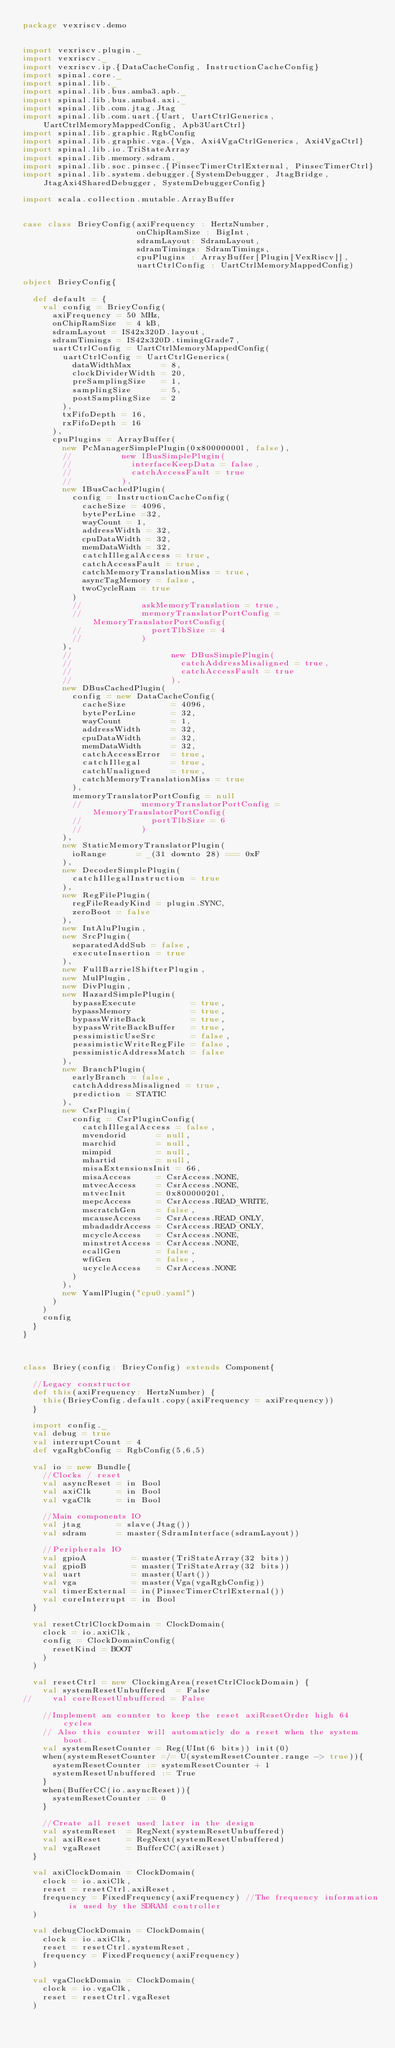Convert code to text. <code><loc_0><loc_0><loc_500><loc_500><_Scala_>package vexriscv.demo


import vexriscv.plugin._
import vexriscv._
import vexriscv.ip.{DataCacheConfig, InstructionCacheConfig}
import spinal.core._
import spinal.lib._
import spinal.lib.bus.amba3.apb._
import spinal.lib.bus.amba4.axi._
import spinal.lib.com.jtag.Jtag
import spinal.lib.com.uart.{Uart, UartCtrlGenerics, UartCtrlMemoryMappedConfig, Apb3UartCtrl}
import spinal.lib.graphic.RgbConfig
import spinal.lib.graphic.vga.{Vga, Axi4VgaCtrlGenerics, Axi4VgaCtrl}
import spinal.lib.io.TriStateArray
import spinal.lib.memory.sdram._
import spinal.lib.soc.pinsec.{PinsecTimerCtrlExternal, PinsecTimerCtrl}
import spinal.lib.system.debugger.{SystemDebugger, JtagBridge, JtagAxi4SharedDebugger, SystemDebuggerConfig}

import scala.collection.mutable.ArrayBuffer


case class BrieyConfig(axiFrequency : HertzNumber,
                       onChipRamSize : BigInt,
                       sdramLayout: SdramLayout,
                       sdramTimings: SdramTimings,
                       cpuPlugins : ArrayBuffer[Plugin[VexRiscv]],
                       uartCtrlConfig : UartCtrlMemoryMappedConfig)

object BrieyConfig{

  def default = {
    val config = BrieyConfig(
      axiFrequency = 50 MHz,
      onChipRamSize  = 4 kB,
      sdramLayout = IS42x320D.layout,
      sdramTimings = IS42x320D.timingGrade7,
      uartCtrlConfig = UartCtrlMemoryMappedConfig(
        uartCtrlConfig = UartCtrlGenerics(
          dataWidthMax      = 8,
          clockDividerWidth = 20,
          preSamplingSize   = 1,
          samplingSize      = 5,
          postSamplingSize  = 2
        ),
        txFifoDepth = 16,
        rxFifoDepth = 16
      ),
      cpuPlugins = ArrayBuffer(
        new PcManagerSimplePlugin(0x80000000l, false),
        //          new IBusSimplePlugin(
        //            interfaceKeepData = false,
        //            catchAccessFault = true
        //          ),
        new IBusCachedPlugin(
          config = InstructionCacheConfig(
            cacheSize = 4096,
            bytePerLine =32,
            wayCount = 1,
            addressWidth = 32,
            cpuDataWidth = 32,
            memDataWidth = 32,
            catchIllegalAccess = true,
            catchAccessFault = true,
            catchMemoryTranslationMiss = true,
            asyncTagMemory = false,
            twoCycleRam = true
          )
          //            askMemoryTranslation = true,
          //            memoryTranslatorPortConfig = MemoryTranslatorPortConfig(
          //              portTlbSize = 4
          //            )
        ),
        //                    new DBusSimplePlugin(
        //                      catchAddressMisaligned = true,
        //                      catchAccessFault = true
        //                    ),
        new DBusCachedPlugin(
          config = new DataCacheConfig(
            cacheSize         = 4096,
            bytePerLine       = 32,
            wayCount          = 1,
            addressWidth      = 32,
            cpuDataWidth      = 32,
            memDataWidth      = 32,
            catchAccessError  = true,
            catchIllegal      = true,
            catchUnaligned    = true,
            catchMemoryTranslationMiss = true
          ),
          memoryTranslatorPortConfig = null
          //            memoryTranslatorPortConfig = MemoryTranslatorPortConfig(
          //              portTlbSize = 6
          //            )
        ),
        new StaticMemoryTranslatorPlugin(
          ioRange      = _(31 downto 28) === 0xF
        ),
        new DecoderSimplePlugin(
          catchIllegalInstruction = true
        ),
        new RegFilePlugin(
          regFileReadyKind = plugin.SYNC,
          zeroBoot = false
        ),
        new IntAluPlugin,
        new SrcPlugin(
          separatedAddSub = false,
          executeInsertion = true
        ),
        new FullBarrielShifterPlugin,
        new MulPlugin,
        new DivPlugin,
        new HazardSimplePlugin(
          bypassExecute           = true,
          bypassMemory            = true,
          bypassWriteBack         = true,
          bypassWriteBackBuffer   = true,
          pessimisticUseSrc       = false,
          pessimisticWriteRegFile = false,
          pessimisticAddressMatch = false
        ),
        new BranchPlugin(
          earlyBranch = false,
          catchAddressMisaligned = true,
          prediction = STATIC
        ),
        new CsrPlugin(
          config = CsrPluginConfig(
            catchIllegalAccess = false,
            mvendorid      = null,
            marchid        = null,
            mimpid         = null,
            mhartid        = null,
            misaExtensionsInit = 66,
            misaAccess     = CsrAccess.NONE,
            mtvecAccess    = CsrAccess.NONE,
            mtvecInit      = 0x80000020l,
            mepcAccess     = CsrAccess.READ_WRITE,
            mscratchGen    = false,
            mcauseAccess   = CsrAccess.READ_ONLY,
            mbadaddrAccess = CsrAccess.READ_ONLY,
            mcycleAccess   = CsrAccess.NONE,
            minstretAccess = CsrAccess.NONE,
            ecallGen       = false,
            wfiGen         = false,
            ucycleAccess   = CsrAccess.NONE
          )
        ),
        new YamlPlugin("cpu0.yaml")
      )
    )
    config
  }
}



class Briey(config: BrieyConfig) extends Component{

  //Legacy constructor
  def this(axiFrequency: HertzNumber) {
    this(BrieyConfig.default.copy(axiFrequency = axiFrequency))
  }

  import config._
  val debug = true
  val interruptCount = 4
  def vgaRgbConfig = RgbConfig(5,6,5)

  val io = new Bundle{
    //Clocks / reset
    val asyncReset = in Bool
    val axiClk     = in Bool
    val vgaClk     = in Bool

    //Main components IO
    val jtag       = slave(Jtag())
    val sdram      = master(SdramInterface(sdramLayout))

    //Peripherals IO
    val gpioA         = master(TriStateArray(32 bits))
    val gpioB         = master(TriStateArray(32 bits))
    val uart          = master(Uart())
    val vga           = master(Vga(vgaRgbConfig))
    val timerExternal = in(PinsecTimerCtrlExternal())
    val coreInterrupt = in Bool
  }

  val resetCtrlClockDomain = ClockDomain(
    clock = io.axiClk,
    config = ClockDomainConfig(
      resetKind = BOOT
    )
  )

  val resetCtrl = new ClockingArea(resetCtrlClockDomain) {
    val systemResetUnbuffered  = False
//    val coreResetUnbuffered = False

    //Implement an counter to keep the reset axiResetOrder high 64 cycles
    // Also this counter will automaticly do a reset when the system boot.
    val systemResetCounter = Reg(UInt(6 bits)) init(0)
    when(systemResetCounter =/= U(systemResetCounter.range -> true)){
      systemResetCounter := systemResetCounter + 1
      systemResetUnbuffered := True
    }
    when(BufferCC(io.asyncReset)){
      systemResetCounter := 0
    }

    //Create all reset used later in the design
    val systemReset  = RegNext(systemResetUnbuffered)
    val axiReset     = RegNext(systemResetUnbuffered)
    val vgaReset     = BufferCC(axiReset)
  }

  val axiClockDomain = ClockDomain(
    clock = io.axiClk,
    reset = resetCtrl.axiReset,
    frequency = FixedFrequency(axiFrequency) //The frequency information is used by the SDRAM controller
  )

  val debugClockDomain = ClockDomain(
    clock = io.axiClk,
    reset = resetCtrl.systemReset,
    frequency = FixedFrequency(axiFrequency)
  )

  val vgaClockDomain = ClockDomain(
    clock = io.vgaClk,
    reset = resetCtrl.vgaReset
  )
</code> 